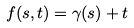<formula> <loc_0><loc_0><loc_500><loc_500>f ( s , t ) = \gamma ( s ) + t</formula> 